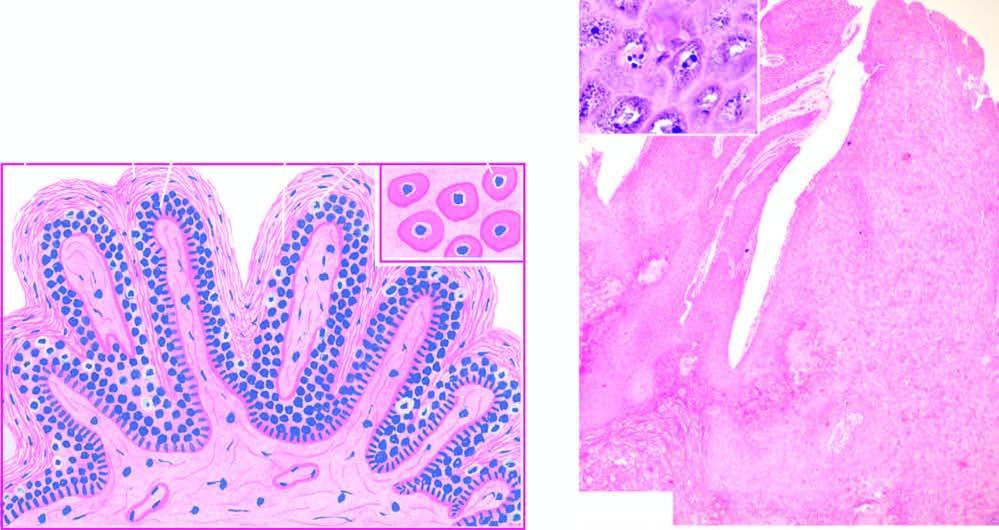what contain prominent keratohyaline granules?
Answer the question using a single word or phrase. Koilocytes and virus-infected keratinocytes 